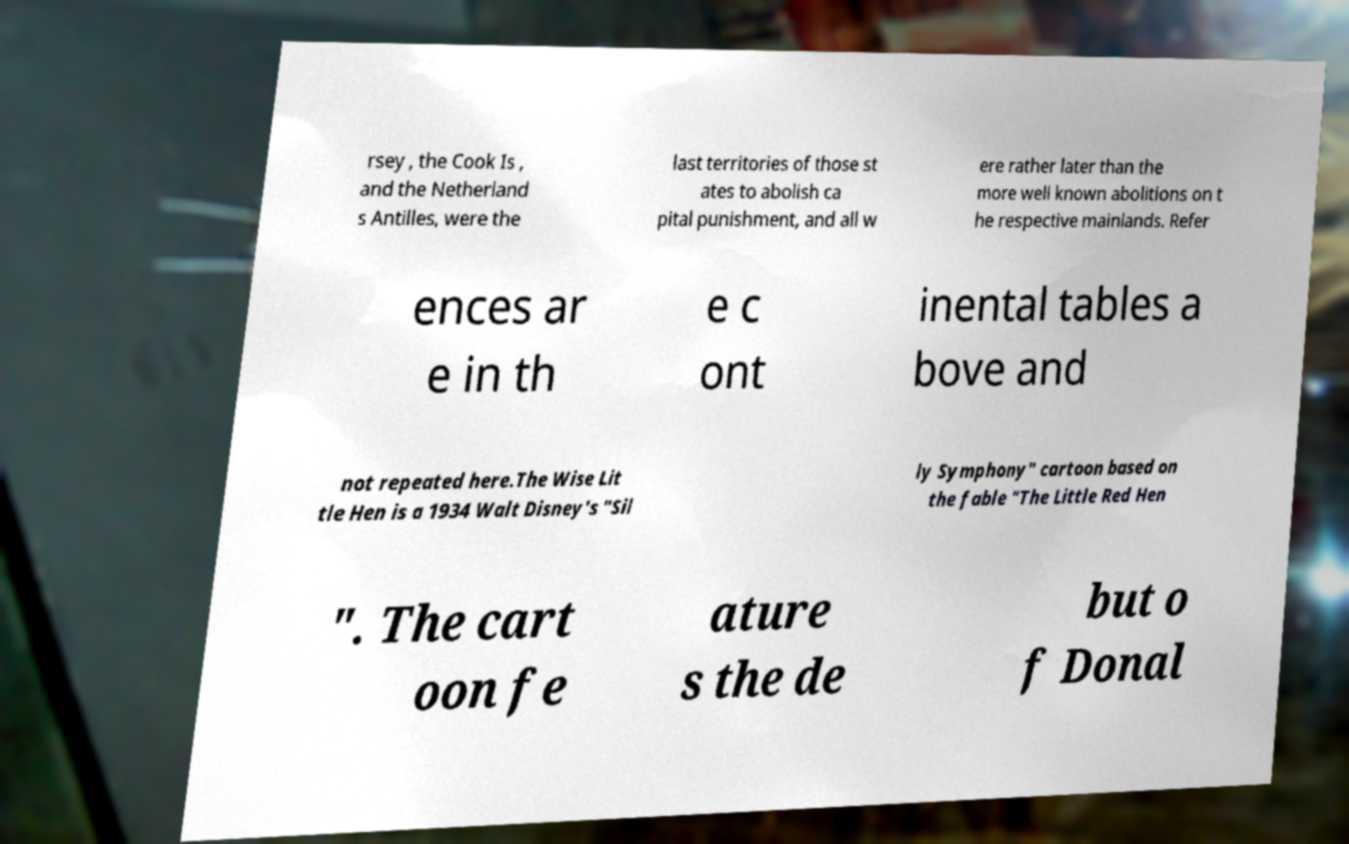I need the written content from this picture converted into text. Can you do that? rsey , the Cook Is , and the Netherland s Antilles, were the last territories of those st ates to abolish ca pital punishment, and all w ere rather later than the more well known abolitions on t he respective mainlands. Refer ences ar e in th e c ont inental tables a bove and not repeated here.The Wise Lit tle Hen is a 1934 Walt Disney's "Sil ly Symphony" cartoon based on the fable "The Little Red Hen ". The cart oon fe ature s the de but o f Donal 